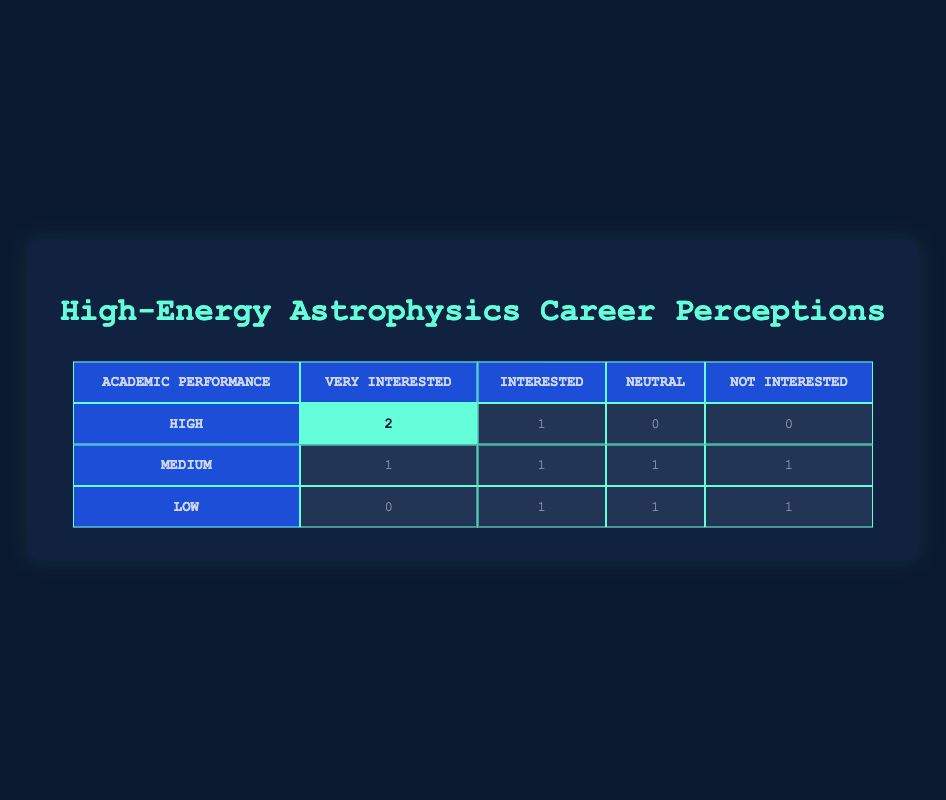What is the number of students with a high academic performance level who are very interested in a career in high-energy astrophysics? From the table, under the row for "High" academic performance, the column for "Very Interested" shows 2 students.
Answer: 2 How many students with a low academic performance level are interested in a career in high-energy astrophysics? Looking at the "Low" row in the "Interested" column, there is 1 student who is classified as "Interested."
Answer: 1 What is the total number of students with medium academic performance that are either very interested or interested in a career in high-energy astrophysics? For "Medium" performance, the table shows 1 student "Very Interested" and 1 student "Interested." Therefore, the total is 1 + 1 = 2.
Answer: 2 Is it true that no students with high academic performance are neutral about a career in high-energy astrophysics? Checking the "High" row under the "Neutral" column, it shows 0 students, making the statement true.
Answer: Yes What is the difference between the number of students with low academic performance who are not interested and those who are very interested in high-energy astrophysics? The "Low" row shows 1 student "Not Interested" and 0 students "Very Interested." The difference is 1 - 0 = 1.
Answer: 1 How many total students participated in this survey regarding high-energy astrophysics perceptions? Adding up all the entries in the table: (2 + 1 + 0 + 0) + (1 + 1 + 1 + 1) + (0 + 1 + 1 + 1) = 10 students total.
Answer: 10 What percentage of students with high academic performance are either very interested or interested in a career? For students with high performance, there are 2 "Very Interested" and 1 "Interested," totaling 3 students. The percentage is (3 out of 3) * 100 = 100%.
Answer: 100% How does the interest level in a high-energy astrophysics career compare between high and medium performance students? High performers have 2 very interested and 1 interested, while medium performers have 1 very interested and 1 interested. This reveals that high performers are more interested overall (3 vs 2).
Answer: High performers are more interested 